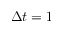<formula> <loc_0><loc_0><loc_500><loc_500>\Delta t = 1</formula> 